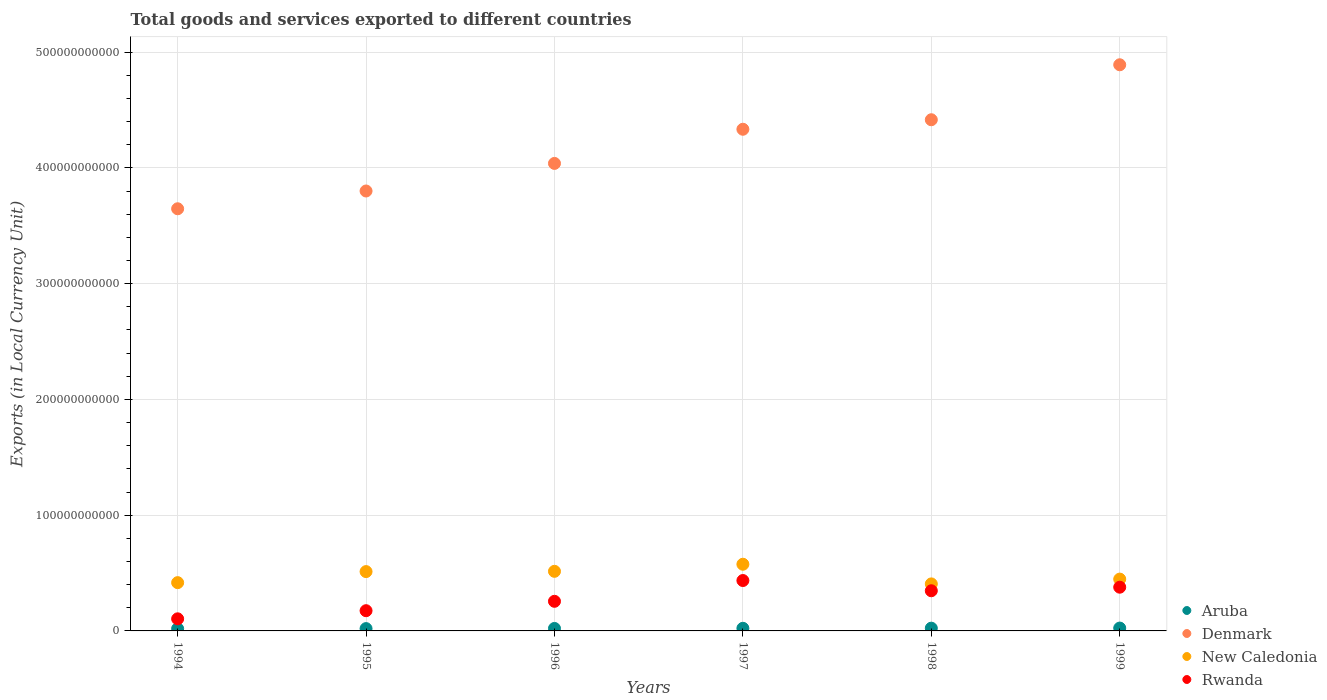What is the Amount of goods and services exports in Rwanda in 1995?
Keep it short and to the point. 1.75e+1. Across all years, what is the maximum Amount of goods and services exports in Aruba?
Ensure brevity in your answer.  2.47e+09. Across all years, what is the minimum Amount of goods and services exports in Rwanda?
Keep it short and to the point. 1.04e+1. In which year was the Amount of goods and services exports in New Caledonia maximum?
Provide a succinct answer. 1997. In which year was the Amount of goods and services exports in New Caledonia minimum?
Keep it short and to the point. 1998. What is the total Amount of goods and services exports in Aruba in the graph?
Offer a terse response. 1.32e+1. What is the difference between the Amount of goods and services exports in New Caledonia in 1994 and that in 1998?
Ensure brevity in your answer.  1.09e+09. What is the difference between the Amount of goods and services exports in Rwanda in 1998 and the Amount of goods and services exports in Aruba in 1997?
Provide a short and direct response. 3.24e+1. What is the average Amount of goods and services exports in Rwanda per year?
Ensure brevity in your answer.  2.82e+1. In the year 1997, what is the difference between the Amount of goods and services exports in Denmark and Amount of goods and services exports in New Caledonia?
Your answer should be compact. 3.76e+11. In how many years, is the Amount of goods and services exports in Rwanda greater than 480000000000 LCU?
Give a very brief answer. 0. What is the ratio of the Amount of goods and services exports in Rwanda in 1997 to that in 1998?
Keep it short and to the point. 1.25. What is the difference between the highest and the second highest Amount of goods and services exports in New Caledonia?
Ensure brevity in your answer.  6.12e+09. What is the difference between the highest and the lowest Amount of goods and services exports in Aruba?
Ensure brevity in your answer.  5.50e+08. Is the sum of the Amount of goods and services exports in Aruba in 1995 and 1997 greater than the maximum Amount of goods and services exports in Rwanda across all years?
Your answer should be very brief. No. Is it the case that in every year, the sum of the Amount of goods and services exports in Denmark and Amount of goods and services exports in Aruba  is greater than the Amount of goods and services exports in New Caledonia?
Offer a terse response. Yes. How many dotlines are there?
Your response must be concise. 4. What is the difference between two consecutive major ticks on the Y-axis?
Give a very brief answer. 1.00e+11. Are the values on the major ticks of Y-axis written in scientific E-notation?
Your answer should be very brief. No. Does the graph contain grids?
Give a very brief answer. Yes. What is the title of the graph?
Your answer should be compact. Total goods and services exported to different countries. What is the label or title of the Y-axis?
Keep it short and to the point. Exports (in Local Currency Unit). What is the Exports (in Local Currency Unit) in Aruba in 1994?
Provide a short and direct response. 1.92e+09. What is the Exports (in Local Currency Unit) in Denmark in 1994?
Your answer should be compact. 3.65e+11. What is the Exports (in Local Currency Unit) of New Caledonia in 1994?
Offer a very short reply. 4.17e+1. What is the Exports (in Local Currency Unit) in Rwanda in 1994?
Ensure brevity in your answer.  1.04e+1. What is the Exports (in Local Currency Unit) of Aruba in 1995?
Give a very brief answer. 2.01e+09. What is the Exports (in Local Currency Unit) in Denmark in 1995?
Your answer should be very brief. 3.80e+11. What is the Exports (in Local Currency Unit) in New Caledonia in 1995?
Offer a very short reply. 5.13e+1. What is the Exports (in Local Currency Unit) in Rwanda in 1995?
Provide a short and direct response. 1.75e+1. What is the Exports (in Local Currency Unit) of Aruba in 1996?
Provide a short and direct response. 2.14e+09. What is the Exports (in Local Currency Unit) of Denmark in 1996?
Provide a short and direct response. 4.04e+11. What is the Exports (in Local Currency Unit) of New Caledonia in 1996?
Make the answer very short. 5.15e+1. What is the Exports (in Local Currency Unit) in Rwanda in 1996?
Ensure brevity in your answer.  2.56e+1. What is the Exports (in Local Currency Unit) of Aruba in 1997?
Offer a terse response. 2.26e+09. What is the Exports (in Local Currency Unit) in Denmark in 1997?
Your answer should be compact. 4.33e+11. What is the Exports (in Local Currency Unit) of New Caledonia in 1997?
Your response must be concise. 5.76e+1. What is the Exports (in Local Currency Unit) in Rwanda in 1997?
Give a very brief answer. 4.35e+1. What is the Exports (in Local Currency Unit) of Aruba in 1998?
Ensure brevity in your answer.  2.37e+09. What is the Exports (in Local Currency Unit) of Denmark in 1998?
Offer a terse response. 4.42e+11. What is the Exports (in Local Currency Unit) of New Caledonia in 1998?
Provide a short and direct response. 4.06e+1. What is the Exports (in Local Currency Unit) of Rwanda in 1998?
Make the answer very short. 3.47e+1. What is the Exports (in Local Currency Unit) in Aruba in 1999?
Offer a very short reply. 2.47e+09. What is the Exports (in Local Currency Unit) in Denmark in 1999?
Keep it short and to the point. 4.89e+11. What is the Exports (in Local Currency Unit) of New Caledonia in 1999?
Offer a terse response. 4.48e+1. What is the Exports (in Local Currency Unit) of Rwanda in 1999?
Offer a very short reply. 3.78e+1. Across all years, what is the maximum Exports (in Local Currency Unit) of Aruba?
Keep it short and to the point. 2.47e+09. Across all years, what is the maximum Exports (in Local Currency Unit) in Denmark?
Give a very brief answer. 4.89e+11. Across all years, what is the maximum Exports (in Local Currency Unit) of New Caledonia?
Ensure brevity in your answer.  5.76e+1. Across all years, what is the maximum Exports (in Local Currency Unit) in Rwanda?
Your answer should be very brief. 4.35e+1. Across all years, what is the minimum Exports (in Local Currency Unit) in Aruba?
Offer a very short reply. 1.92e+09. Across all years, what is the minimum Exports (in Local Currency Unit) in Denmark?
Your answer should be compact. 3.65e+11. Across all years, what is the minimum Exports (in Local Currency Unit) of New Caledonia?
Offer a terse response. 4.06e+1. Across all years, what is the minimum Exports (in Local Currency Unit) in Rwanda?
Make the answer very short. 1.04e+1. What is the total Exports (in Local Currency Unit) of Aruba in the graph?
Your response must be concise. 1.32e+1. What is the total Exports (in Local Currency Unit) of Denmark in the graph?
Make the answer very short. 2.51e+12. What is the total Exports (in Local Currency Unit) of New Caledonia in the graph?
Give a very brief answer. 2.87e+11. What is the total Exports (in Local Currency Unit) of Rwanda in the graph?
Provide a short and direct response. 1.69e+11. What is the difference between the Exports (in Local Currency Unit) of Aruba in 1994 and that in 1995?
Make the answer very short. -9.10e+07. What is the difference between the Exports (in Local Currency Unit) of Denmark in 1994 and that in 1995?
Provide a short and direct response. -1.53e+1. What is the difference between the Exports (in Local Currency Unit) in New Caledonia in 1994 and that in 1995?
Keep it short and to the point. -9.54e+09. What is the difference between the Exports (in Local Currency Unit) in Rwanda in 1994 and that in 1995?
Your response must be concise. -7.02e+09. What is the difference between the Exports (in Local Currency Unit) in Aruba in 1994 and that in 1996?
Offer a very short reply. -2.25e+08. What is the difference between the Exports (in Local Currency Unit) in Denmark in 1994 and that in 1996?
Make the answer very short. -3.92e+1. What is the difference between the Exports (in Local Currency Unit) in New Caledonia in 1994 and that in 1996?
Your answer should be very brief. -9.78e+09. What is the difference between the Exports (in Local Currency Unit) of Rwanda in 1994 and that in 1996?
Keep it short and to the point. -1.51e+1. What is the difference between the Exports (in Local Currency Unit) of Aruba in 1994 and that in 1997?
Your response must be concise. -3.48e+08. What is the difference between the Exports (in Local Currency Unit) of Denmark in 1994 and that in 1997?
Give a very brief answer. -6.87e+1. What is the difference between the Exports (in Local Currency Unit) of New Caledonia in 1994 and that in 1997?
Provide a succinct answer. -1.59e+1. What is the difference between the Exports (in Local Currency Unit) in Rwanda in 1994 and that in 1997?
Your answer should be very brief. -3.31e+1. What is the difference between the Exports (in Local Currency Unit) in Aruba in 1994 and that in 1998?
Offer a terse response. -4.59e+08. What is the difference between the Exports (in Local Currency Unit) of Denmark in 1994 and that in 1998?
Your response must be concise. -7.69e+1. What is the difference between the Exports (in Local Currency Unit) of New Caledonia in 1994 and that in 1998?
Ensure brevity in your answer.  1.09e+09. What is the difference between the Exports (in Local Currency Unit) of Rwanda in 1994 and that in 1998?
Provide a succinct answer. -2.43e+1. What is the difference between the Exports (in Local Currency Unit) in Aruba in 1994 and that in 1999?
Offer a very short reply. -5.50e+08. What is the difference between the Exports (in Local Currency Unit) of Denmark in 1994 and that in 1999?
Offer a terse response. -1.24e+11. What is the difference between the Exports (in Local Currency Unit) of New Caledonia in 1994 and that in 1999?
Offer a very short reply. -3.06e+09. What is the difference between the Exports (in Local Currency Unit) of Rwanda in 1994 and that in 1999?
Your answer should be very brief. -2.73e+1. What is the difference between the Exports (in Local Currency Unit) of Aruba in 1995 and that in 1996?
Your answer should be compact. -1.34e+08. What is the difference between the Exports (in Local Currency Unit) in Denmark in 1995 and that in 1996?
Your answer should be very brief. -2.38e+1. What is the difference between the Exports (in Local Currency Unit) of New Caledonia in 1995 and that in 1996?
Provide a succinct answer. -2.33e+08. What is the difference between the Exports (in Local Currency Unit) of Rwanda in 1995 and that in 1996?
Give a very brief answer. -8.11e+09. What is the difference between the Exports (in Local Currency Unit) of Aruba in 1995 and that in 1997?
Offer a terse response. -2.57e+08. What is the difference between the Exports (in Local Currency Unit) of Denmark in 1995 and that in 1997?
Provide a short and direct response. -5.33e+1. What is the difference between the Exports (in Local Currency Unit) in New Caledonia in 1995 and that in 1997?
Give a very brief answer. -6.35e+09. What is the difference between the Exports (in Local Currency Unit) of Rwanda in 1995 and that in 1997?
Your answer should be very brief. -2.61e+1. What is the difference between the Exports (in Local Currency Unit) of Aruba in 1995 and that in 1998?
Make the answer very short. -3.68e+08. What is the difference between the Exports (in Local Currency Unit) in Denmark in 1995 and that in 1998?
Ensure brevity in your answer.  -6.16e+1. What is the difference between the Exports (in Local Currency Unit) of New Caledonia in 1995 and that in 1998?
Ensure brevity in your answer.  1.06e+1. What is the difference between the Exports (in Local Currency Unit) of Rwanda in 1995 and that in 1998?
Make the answer very short. -1.72e+1. What is the difference between the Exports (in Local Currency Unit) in Aruba in 1995 and that in 1999?
Provide a short and direct response. -4.59e+08. What is the difference between the Exports (in Local Currency Unit) in Denmark in 1995 and that in 1999?
Keep it short and to the point. -1.09e+11. What is the difference between the Exports (in Local Currency Unit) of New Caledonia in 1995 and that in 1999?
Your response must be concise. 6.49e+09. What is the difference between the Exports (in Local Currency Unit) in Rwanda in 1995 and that in 1999?
Make the answer very short. -2.03e+1. What is the difference between the Exports (in Local Currency Unit) of Aruba in 1996 and that in 1997?
Make the answer very short. -1.23e+08. What is the difference between the Exports (in Local Currency Unit) of Denmark in 1996 and that in 1997?
Your answer should be compact. -2.95e+1. What is the difference between the Exports (in Local Currency Unit) of New Caledonia in 1996 and that in 1997?
Your answer should be compact. -6.12e+09. What is the difference between the Exports (in Local Currency Unit) in Rwanda in 1996 and that in 1997?
Ensure brevity in your answer.  -1.80e+1. What is the difference between the Exports (in Local Currency Unit) in Aruba in 1996 and that in 1998?
Give a very brief answer. -2.34e+08. What is the difference between the Exports (in Local Currency Unit) of Denmark in 1996 and that in 1998?
Ensure brevity in your answer.  -3.77e+1. What is the difference between the Exports (in Local Currency Unit) of New Caledonia in 1996 and that in 1998?
Your answer should be very brief. 1.09e+1. What is the difference between the Exports (in Local Currency Unit) of Rwanda in 1996 and that in 1998?
Ensure brevity in your answer.  -9.12e+09. What is the difference between the Exports (in Local Currency Unit) in Aruba in 1996 and that in 1999?
Your response must be concise. -3.25e+08. What is the difference between the Exports (in Local Currency Unit) in Denmark in 1996 and that in 1999?
Keep it short and to the point. -8.52e+1. What is the difference between the Exports (in Local Currency Unit) of New Caledonia in 1996 and that in 1999?
Provide a short and direct response. 6.72e+09. What is the difference between the Exports (in Local Currency Unit) in Rwanda in 1996 and that in 1999?
Provide a succinct answer. -1.22e+1. What is the difference between the Exports (in Local Currency Unit) of Aruba in 1997 and that in 1998?
Offer a very short reply. -1.11e+08. What is the difference between the Exports (in Local Currency Unit) in Denmark in 1997 and that in 1998?
Give a very brief answer. -8.22e+09. What is the difference between the Exports (in Local Currency Unit) of New Caledonia in 1997 and that in 1998?
Keep it short and to the point. 1.70e+1. What is the difference between the Exports (in Local Currency Unit) in Rwanda in 1997 and that in 1998?
Ensure brevity in your answer.  8.83e+09. What is the difference between the Exports (in Local Currency Unit) of Aruba in 1997 and that in 1999?
Your response must be concise. -2.02e+08. What is the difference between the Exports (in Local Currency Unit) in Denmark in 1997 and that in 1999?
Provide a succinct answer. -5.57e+1. What is the difference between the Exports (in Local Currency Unit) of New Caledonia in 1997 and that in 1999?
Offer a very short reply. 1.28e+1. What is the difference between the Exports (in Local Currency Unit) in Rwanda in 1997 and that in 1999?
Give a very brief answer. 5.77e+09. What is the difference between the Exports (in Local Currency Unit) of Aruba in 1998 and that in 1999?
Offer a very short reply. -9.15e+07. What is the difference between the Exports (in Local Currency Unit) in Denmark in 1998 and that in 1999?
Ensure brevity in your answer.  -4.75e+1. What is the difference between the Exports (in Local Currency Unit) of New Caledonia in 1998 and that in 1999?
Your response must be concise. -4.14e+09. What is the difference between the Exports (in Local Currency Unit) in Rwanda in 1998 and that in 1999?
Your response must be concise. -3.07e+09. What is the difference between the Exports (in Local Currency Unit) in Aruba in 1994 and the Exports (in Local Currency Unit) in Denmark in 1995?
Make the answer very short. -3.78e+11. What is the difference between the Exports (in Local Currency Unit) in Aruba in 1994 and the Exports (in Local Currency Unit) in New Caledonia in 1995?
Keep it short and to the point. -4.93e+1. What is the difference between the Exports (in Local Currency Unit) in Aruba in 1994 and the Exports (in Local Currency Unit) in Rwanda in 1995?
Your answer should be very brief. -1.56e+1. What is the difference between the Exports (in Local Currency Unit) in Denmark in 1994 and the Exports (in Local Currency Unit) in New Caledonia in 1995?
Provide a short and direct response. 3.13e+11. What is the difference between the Exports (in Local Currency Unit) in Denmark in 1994 and the Exports (in Local Currency Unit) in Rwanda in 1995?
Your answer should be compact. 3.47e+11. What is the difference between the Exports (in Local Currency Unit) in New Caledonia in 1994 and the Exports (in Local Currency Unit) in Rwanda in 1995?
Provide a succinct answer. 2.42e+1. What is the difference between the Exports (in Local Currency Unit) of Aruba in 1994 and the Exports (in Local Currency Unit) of Denmark in 1996?
Give a very brief answer. -4.02e+11. What is the difference between the Exports (in Local Currency Unit) of Aruba in 1994 and the Exports (in Local Currency Unit) of New Caledonia in 1996?
Make the answer very short. -4.96e+1. What is the difference between the Exports (in Local Currency Unit) of Aruba in 1994 and the Exports (in Local Currency Unit) of Rwanda in 1996?
Keep it short and to the point. -2.37e+1. What is the difference between the Exports (in Local Currency Unit) in Denmark in 1994 and the Exports (in Local Currency Unit) in New Caledonia in 1996?
Offer a terse response. 3.13e+11. What is the difference between the Exports (in Local Currency Unit) of Denmark in 1994 and the Exports (in Local Currency Unit) of Rwanda in 1996?
Ensure brevity in your answer.  3.39e+11. What is the difference between the Exports (in Local Currency Unit) of New Caledonia in 1994 and the Exports (in Local Currency Unit) of Rwanda in 1996?
Give a very brief answer. 1.61e+1. What is the difference between the Exports (in Local Currency Unit) of Aruba in 1994 and the Exports (in Local Currency Unit) of Denmark in 1997?
Ensure brevity in your answer.  -4.31e+11. What is the difference between the Exports (in Local Currency Unit) in Aruba in 1994 and the Exports (in Local Currency Unit) in New Caledonia in 1997?
Your answer should be very brief. -5.57e+1. What is the difference between the Exports (in Local Currency Unit) in Aruba in 1994 and the Exports (in Local Currency Unit) in Rwanda in 1997?
Your answer should be very brief. -4.16e+1. What is the difference between the Exports (in Local Currency Unit) of Denmark in 1994 and the Exports (in Local Currency Unit) of New Caledonia in 1997?
Ensure brevity in your answer.  3.07e+11. What is the difference between the Exports (in Local Currency Unit) of Denmark in 1994 and the Exports (in Local Currency Unit) of Rwanda in 1997?
Make the answer very short. 3.21e+11. What is the difference between the Exports (in Local Currency Unit) in New Caledonia in 1994 and the Exports (in Local Currency Unit) in Rwanda in 1997?
Your response must be concise. -1.83e+09. What is the difference between the Exports (in Local Currency Unit) in Aruba in 1994 and the Exports (in Local Currency Unit) in Denmark in 1998?
Keep it short and to the point. -4.40e+11. What is the difference between the Exports (in Local Currency Unit) of Aruba in 1994 and the Exports (in Local Currency Unit) of New Caledonia in 1998?
Make the answer very short. -3.87e+1. What is the difference between the Exports (in Local Currency Unit) of Aruba in 1994 and the Exports (in Local Currency Unit) of Rwanda in 1998?
Your response must be concise. -3.28e+1. What is the difference between the Exports (in Local Currency Unit) of Denmark in 1994 and the Exports (in Local Currency Unit) of New Caledonia in 1998?
Provide a succinct answer. 3.24e+11. What is the difference between the Exports (in Local Currency Unit) in Denmark in 1994 and the Exports (in Local Currency Unit) in Rwanda in 1998?
Provide a short and direct response. 3.30e+11. What is the difference between the Exports (in Local Currency Unit) of New Caledonia in 1994 and the Exports (in Local Currency Unit) of Rwanda in 1998?
Ensure brevity in your answer.  7.01e+09. What is the difference between the Exports (in Local Currency Unit) in Aruba in 1994 and the Exports (in Local Currency Unit) in Denmark in 1999?
Keep it short and to the point. -4.87e+11. What is the difference between the Exports (in Local Currency Unit) of Aruba in 1994 and the Exports (in Local Currency Unit) of New Caledonia in 1999?
Your response must be concise. -4.28e+1. What is the difference between the Exports (in Local Currency Unit) of Aruba in 1994 and the Exports (in Local Currency Unit) of Rwanda in 1999?
Make the answer very short. -3.59e+1. What is the difference between the Exports (in Local Currency Unit) in Denmark in 1994 and the Exports (in Local Currency Unit) in New Caledonia in 1999?
Offer a terse response. 3.20e+11. What is the difference between the Exports (in Local Currency Unit) of Denmark in 1994 and the Exports (in Local Currency Unit) of Rwanda in 1999?
Your answer should be compact. 3.27e+11. What is the difference between the Exports (in Local Currency Unit) in New Caledonia in 1994 and the Exports (in Local Currency Unit) in Rwanda in 1999?
Offer a terse response. 3.94e+09. What is the difference between the Exports (in Local Currency Unit) in Aruba in 1995 and the Exports (in Local Currency Unit) in Denmark in 1996?
Your answer should be compact. -4.02e+11. What is the difference between the Exports (in Local Currency Unit) of Aruba in 1995 and the Exports (in Local Currency Unit) of New Caledonia in 1996?
Give a very brief answer. -4.95e+1. What is the difference between the Exports (in Local Currency Unit) of Aruba in 1995 and the Exports (in Local Currency Unit) of Rwanda in 1996?
Your answer should be very brief. -2.36e+1. What is the difference between the Exports (in Local Currency Unit) in Denmark in 1995 and the Exports (in Local Currency Unit) in New Caledonia in 1996?
Give a very brief answer. 3.29e+11. What is the difference between the Exports (in Local Currency Unit) of Denmark in 1995 and the Exports (in Local Currency Unit) of Rwanda in 1996?
Offer a very short reply. 3.54e+11. What is the difference between the Exports (in Local Currency Unit) of New Caledonia in 1995 and the Exports (in Local Currency Unit) of Rwanda in 1996?
Ensure brevity in your answer.  2.57e+1. What is the difference between the Exports (in Local Currency Unit) of Aruba in 1995 and the Exports (in Local Currency Unit) of Denmark in 1997?
Provide a succinct answer. -4.31e+11. What is the difference between the Exports (in Local Currency Unit) of Aruba in 1995 and the Exports (in Local Currency Unit) of New Caledonia in 1997?
Your answer should be very brief. -5.56e+1. What is the difference between the Exports (in Local Currency Unit) in Aruba in 1995 and the Exports (in Local Currency Unit) in Rwanda in 1997?
Provide a short and direct response. -4.15e+1. What is the difference between the Exports (in Local Currency Unit) in Denmark in 1995 and the Exports (in Local Currency Unit) in New Caledonia in 1997?
Provide a succinct answer. 3.22e+11. What is the difference between the Exports (in Local Currency Unit) in Denmark in 1995 and the Exports (in Local Currency Unit) in Rwanda in 1997?
Offer a very short reply. 3.37e+11. What is the difference between the Exports (in Local Currency Unit) of New Caledonia in 1995 and the Exports (in Local Currency Unit) of Rwanda in 1997?
Your response must be concise. 7.72e+09. What is the difference between the Exports (in Local Currency Unit) of Aruba in 1995 and the Exports (in Local Currency Unit) of Denmark in 1998?
Provide a short and direct response. -4.40e+11. What is the difference between the Exports (in Local Currency Unit) of Aruba in 1995 and the Exports (in Local Currency Unit) of New Caledonia in 1998?
Keep it short and to the point. -3.86e+1. What is the difference between the Exports (in Local Currency Unit) in Aruba in 1995 and the Exports (in Local Currency Unit) in Rwanda in 1998?
Make the answer very short. -3.27e+1. What is the difference between the Exports (in Local Currency Unit) in Denmark in 1995 and the Exports (in Local Currency Unit) in New Caledonia in 1998?
Your answer should be very brief. 3.39e+11. What is the difference between the Exports (in Local Currency Unit) in Denmark in 1995 and the Exports (in Local Currency Unit) in Rwanda in 1998?
Your response must be concise. 3.45e+11. What is the difference between the Exports (in Local Currency Unit) of New Caledonia in 1995 and the Exports (in Local Currency Unit) of Rwanda in 1998?
Provide a short and direct response. 1.66e+1. What is the difference between the Exports (in Local Currency Unit) in Aruba in 1995 and the Exports (in Local Currency Unit) in Denmark in 1999?
Provide a short and direct response. -4.87e+11. What is the difference between the Exports (in Local Currency Unit) of Aruba in 1995 and the Exports (in Local Currency Unit) of New Caledonia in 1999?
Your answer should be compact. -4.28e+1. What is the difference between the Exports (in Local Currency Unit) in Aruba in 1995 and the Exports (in Local Currency Unit) in Rwanda in 1999?
Keep it short and to the point. -3.58e+1. What is the difference between the Exports (in Local Currency Unit) of Denmark in 1995 and the Exports (in Local Currency Unit) of New Caledonia in 1999?
Your answer should be very brief. 3.35e+11. What is the difference between the Exports (in Local Currency Unit) of Denmark in 1995 and the Exports (in Local Currency Unit) of Rwanda in 1999?
Provide a short and direct response. 3.42e+11. What is the difference between the Exports (in Local Currency Unit) in New Caledonia in 1995 and the Exports (in Local Currency Unit) in Rwanda in 1999?
Your answer should be compact. 1.35e+1. What is the difference between the Exports (in Local Currency Unit) in Aruba in 1996 and the Exports (in Local Currency Unit) in Denmark in 1997?
Ensure brevity in your answer.  -4.31e+11. What is the difference between the Exports (in Local Currency Unit) of Aruba in 1996 and the Exports (in Local Currency Unit) of New Caledonia in 1997?
Give a very brief answer. -5.55e+1. What is the difference between the Exports (in Local Currency Unit) of Aruba in 1996 and the Exports (in Local Currency Unit) of Rwanda in 1997?
Provide a succinct answer. -4.14e+1. What is the difference between the Exports (in Local Currency Unit) of Denmark in 1996 and the Exports (in Local Currency Unit) of New Caledonia in 1997?
Provide a short and direct response. 3.46e+11. What is the difference between the Exports (in Local Currency Unit) in Denmark in 1996 and the Exports (in Local Currency Unit) in Rwanda in 1997?
Offer a very short reply. 3.60e+11. What is the difference between the Exports (in Local Currency Unit) in New Caledonia in 1996 and the Exports (in Local Currency Unit) in Rwanda in 1997?
Make the answer very short. 7.95e+09. What is the difference between the Exports (in Local Currency Unit) in Aruba in 1996 and the Exports (in Local Currency Unit) in Denmark in 1998?
Keep it short and to the point. -4.39e+11. What is the difference between the Exports (in Local Currency Unit) of Aruba in 1996 and the Exports (in Local Currency Unit) of New Caledonia in 1998?
Give a very brief answer. -3.85e+1. What is the difference between the Exports (in Local Currency Unit) of Aruba in 1996 and the Exports (in Local Currency Unit) of Rwanda in 1998?
Provide a succinct answer. -3.26e+1. What is the difference between the Exports (in Local Currency Unit) of Denmark in 1996 and the Exports (in Local Currency Unit) of New Caledonia in 1998?
Keep it short and to the point. 3.63e+11. What is the difference between the Exports (in Local Currency Unit) in Denmark in 1996 and the Exports (in Local Currency Unit) in Rwanda in 1998?
Your response must be concise. 3.69e+11. What is the difference between the Exports (in Local Currency Unit) in New Caledonia in 1996 and the Exports (in Local Currency Unit) in Rwanda in 1998?
Offer a very short reply. 1.68e+1. What is the difference between the Exports (in Local Currency Unit) of Aruba in 1996 and the Exports (in Local Currency Unit) of Denmark in 1999?
Offer a very short reply. -4.87e+11. What is the difference between the Exports (in Local Currency Unit) in Aruba in 1996 and the Exports (in Local Currency Unit) in New Caledonia in 1999?
Your response must be concise. -4.26e+1. What is the difference between the Exports (in Local Currency Unit) in Aruba in 1996 and the Exports (in Local Currency Unit) in Rwanda in 1999?
Provide a short and direct response. -3.56e+1. What is the difference between the Exports (in Local Currency Unit) of Denmark in 1996 and the Exports (in Local Currency Unit) of New Caledonia in 1999?
Ensure brevity in your answer.  3.59e+11. What is the difference between the Exports (in Local Currency Unit) of Denmark in 1996 and the Exports (in Local Currency Unit) of Rwanda in 1999?
Your answer should be compact. 3.66e+11. What is the difference between the Exports (in Local Currency Unit) of New Caledonia in 1996 and the Exports (in Local Currency Unit) of Rwanda in 1999?
Keep it short and to the point. 1.37e+1. What is the difference between the Exports (in Local Currency Unit) of Aruba in 1997 and the Exports (in Local Currency Unit) of Denmark in 1998?
Provide a succinct answer. -4.39e+11. What is the difference between the Exports (in Local Currency Unit) of Aruba in 1997 and the Exports (in Local Currency Unit) of New Caledonia in 1998?
Give a very brief answer. -3.84e+1. What is the difference between the Exports (in Local Currency Unit) in Aruba in 1997 and the Exports (in Local Currency Unit) in Rwanda in 1998?
Your answer should be very brief. -3.24e+1. What is the difference between the Exports (in Local Currency Unit) of Denmark in 1997 and the Exports (in Local Currency Unit) of New Caledonia in 1998?
Offer a very short reply. 3.93e+11. What is the difference between the Exports (in Local Currency Unit) in Denmark in 1997 and the Exports (in Local Currency Unit) in Rwanda in 1998?
Offer a very short reply. 3.99e+11. What is the difference between the Exports (in Local Currency Unit) of New Caledonia in 1997 and the Exports (in Local Currency Unit) of Rwanda in 1998?
Offer a very short reply. 2.29e+1. What is the difference between the Exports (in Local Currency Unit) of Aruba in 1997 and the Exports (in Local Currency Unit) of Denmark in 1999?
Offer a very short reply. -4.87e+11. What is the difference between the Exports (in Local Currency Unit) in Aruba in 1997 and the Exports (in Local Currency Unit) in New Caledonia in 1999?
Provide a short and direct response. -4.25e+1. What is the difference between the Exports (in Local Currency Unit) of Aruba in 1997 and the Exports (in Local Currency Unit) of Rwanda in 1999?
Give a very brief answer. -3.55e+1. What is the difference between the Exports (in Local Currency Unit) in Denmark in 1997 and the Exports (in Local Currency Unit) in New Caledonia in 1999?
Offer a very short reply. 3.89e+11. What is the difference between the Exports (in Local Currency Unit) of Denmark in 1997 and the Exports (in Local Currency Unit) of Rwanda in 1999?
Provide a succinct answer. 3.96e+11. What is the difference between the Exports (in Local Currency Unit) of New Caledonia in 1997 and the Exports (in Local Currency Unit) of Rwanda in 1999?
Keep it short and to the point. 1.98e+1. What is the difference between the Exports (in Local Currency Unit) in Aruba in 1998 and the Exports (in Local Currency Unit) in Denmark in 1999?
Your answer should be compact. -4.87e+11. What is the difference between the Exports (in Local Currency Unit) of Aruba in 1998 and the Exports (in Local Currency Unit) of New Caledonia in 1999?
Ensure brevity in your answer.  -4.24e+1. What is the difference between the Exports (in Local Currency Unit) of Aruba in 1998 and the Exports (in Local Currency Unit) of Rwanda in 1999?
Make the answer very short. -3.54e+1. What is the difference between the Exports (in Local Currency Unit) of Denmark in 1998 and the Exports (in Local Currency Unit) of New Caledonia in 1999?
Ensure brevity in your answer.  3.97e+11. What is the difference between the Exports (in Local Currency Unit) in Denmark in 1998 and the Exports (in Local Currency Unit) in Rwanda in 1999?
Give a very brief answer. 4.04e+11. What is the difference between the Exports (in Local Currency Unit) of New Caledonia in 1998 and the Exports (in Local Currency Unit) of Rwanda in 1999?
Your answer should be compact. 2.85e+09. What is the average Exports (in Local Currency Unit) in Aruba per year?
Offer a very short reply. 2.19e+09. What is the average Exports (in Local Currency Unit) in Denmark per year?
Your response must be concise. 4.19e+11. What is the average Exports (in Local Currency Unit) in New Caledonia per year?
Provide a succinct answer. 4.79e+1. What is the average Exports (in Local Currency Unit) of Rwanda per year?
Provide a short and direct response. 2.82e+1. In the year 1994, what is the difference between the Exports (in Local Currency Unit) in Aruba and Exports (in Local Currency Unit) in Denmark?
Your response must be concise. -3.63e+11. In the year 1994, what is the difference between the Exports (in Local Currency Unit) of Aruba and Exports (in Local Currency Unit) of New Caledonia?
Your response must be concise. -3.98e+1. In the year 1994, what is the difference between the Exports (in Local Currency Unit) of Aruba and Exports (in Local Currency Unit) of Rwanda?
Your response must be concise. -8.53e+09. In the year 1994, what is the difference between the Exports (in Local Currency Unit) in Denmark and Exports (in Local Currency Unit) in New Caledonia?
Your answer should be compact. 3.23e+11. In the year 1994, what is the difference between the Exports (in Local Currency Unit) of Denmark and Exports (in Local Currency Unit) of Rwanda?
Give a very brief answer. 3.54e+11. In the year 1994, what is the difference between the Exports (in Local Currency Unit) in New Caledonia and Exports (in Local Currency Unit) in Rwanda?
Your answer should be very brief. 3.13e+1. In the year 1995, what is the difference between the Exports (in Local Currency Unit) of Aruba and Exports (in Local Currency Unit) of Denmark?
Your answer should be very brief. -3.78e+11. In the year 1995, what is the difference between the Exports (in Local Currency Unit) in Aruba and Exports (in Local Currency Unit) in New Caledonia?
Give a very brief answer. -4.92e+1. In the year 1995, what is the difference between the Exports (in Local Currency Unit) in Aruba and Exports (in Local Currency Unit) in Rwanda?
Provide a succinct answer. -1.55e+1. In the year 1995, what is the difference between the Exports (in Local Currency Unit) in Denmark and Exports (in Local Currency Unit) in New Caledonia?
Make the answer very short. 3.29e+11. In the year 1995, what is the difference between the Exports (in Local Currency Unit) of Denmark and Exports (in Local Currency Unit) of Rwanda?
Make the answer very short. 3.63e+11. In the year 1995, what is the difference between the Exports (in Local Currency Unit) of New Caledonia and Exports (in Local Currency Unit) of Rwanda?
Your answer should be compact. 3.38e+1. In the year 1996, what is the difference between the Exports (in Local Currency Unit) in Aruba and Exports (in Local Currency Unit) in Denmark?
Keep it short and to the point. -4.02e+11. In the year 1996, what is the difference between the Exports (in Local Currency Unit) of Aruba and Exports (in Local Currency Unit) of New Caledonia?
Ensure brevity in your answer.  -4.93e+1. In the year 1996, what is the difference between the Exports (in Local Currency Unit) of Aruba and Exports (in Local Currency Unit) of Rwanda?
Provide a succinct answer. -2.34e+1. In the year 1996, what is the difference between the Exports (in Local Currency Unit) of Denmark and Exports (in Local Currency Unit) of New Caledonia?
Provide a succinct answer. 3.52e+11. In the year 1996, what is the difference between the Exports (in Local Currency Unit) of Denmark and Exports (in Local Currency Unit) of Rwanda?
Provide a short and direct response. 3.78e+11. In the year 1996, what is the difference between the Exports (in Local Currency Unit) in New Caledonia and Exports (in Local Currency Unit) in Rwanda?
Give a very brief answer. 2.59e+1. In the year 1997, what is the difference between the Exports (in Local Currency Unit) in Aruba and Exports (in Local Currency Unit) in Denmark?
Make the answer very short. -4.31e+11. In the year 1997, what is the difference between the Exports (in Local Currency Unit) of Aruba and Exports (in Local Currency Unit) of New Caledonia?
Give a very brief answer. -5.53e+1. In the year 1997, what is the difference between the Exports (in Local Currency Unit) in Aruba and Exports (in Local Currency Unit) in Rwanda?
Make the answer very short. -4.13e+1. In the year 1997, what is the difference between the Exports (in Local Currency Unit) of Denmark and Exports (in Local Currency Unit) of New Caledonia?
Ensure brevity in your answer.  3.76e+11. In the year 1997, what is the difference between the Exports (in Local Currency Unit) in Denmark and Exports (in Local Currency Unit) in Rwanda?
Ensure brevity in your answer.  3.90e+11. In the year 1997, what is the difference between the Exports (in Local Currency Unit) of New Caledonia and Exports (in Local Currency Unit) of Rwanda?
Your response must be concise. 1.41e+1. In the year 1998, what is the difference between the Exports (in Local Currency Unit) of Aruba and Exports (in Local Currency Unit) of Denmark?
Your answer should be very brief. -4.39e+11. In the year 1998, what is the difference between the Exports (in Local Currency Unit) in Aruba and Exports (in Local Currency Unit) in New Caledonia?
Ensure brevity in your answer.  -3.82e+1. In the year 1998, what is the difference between the Exports (in Local Currency Unit) of Aruba and Exports (in Local Currency Unit) of Rwanda?
Your answer should be compact. -3.23e+1. In the year 1998, what is the difference between the Exports (in Local Currency Unit) in Denmark and Exports (in Local Currency Unit) in New Caledonia?
Provide a short and direct response. 4.01e+11. In the year 1998, what is the difference between the Exports (in Local Currency Unit) in Denmark and Exports (in Local Currency Unit) in Rwanda?
Give a very brief answer. 4.07e+11. In the year 1998, what is the difference between the Exports (in Local Currency Unit) in New Caledonia and Exports (in Local Currency Unit) in Rwanda?
Your response must be concise. 5.92e+09. In the year 1999, what is the difference between the Exports (in Local Currency Unit) in Aruba and Exports (in Local Currency Unit) in Denmark?
Give a very brief answer. -4.87e+11. In the year 1999, what is the difference between the Exports (in Local Currency Unit) in Aruba and Exports (in Local Currency Unit) in New Caledonia?
Your answer should be compact. -4.23e+1. In the year 1999, what is the difference between the Exports (in Local Currency Unit) of Aruba and Exports (in Local Currency Unit) of Rwanda?
Provide a succinct answer. -3.53e+1. In the year 1999, what is the difference between the Exports (in Local Currency Unit) in Denmark and Exports (in Local Currency Unit) in New Caledonia?
Keep it short and to the point. 4.44e+11. In the year 1999, what is the difference between the Exports (in Local Currency Unit) in Denmark and Exports (in Local Currency Unit) in Rwanda?
Provide a succinct answer. 4.51e+11. In the year 1999, what is the difference between the Exports (in Local Currency Unit) of New Caledonia and Exports (in Local Currency Unit) of Rwanda?
Make the answer very short. 7.00e+09. What is the ratio of the Exports (in Local Currency Unit) in Aruba in 1994 to that in 1995?
Offer a very short reply. 0.95. What is the ratio of the Exports (in Local Currency Unit) in Denmark in 1994 to that in 1995?
Your answer should be very brief. 0.96. What is the ratio of the Exports (in Local Currency Unit) in New Caledonia in 1994 to that in 1995?
Offer a terse response. 0.81. What is the ratio of the Exports (in Local Currency Unit) of Rwanda in 1994 to that in 1995?
Your response must be concise. 0.6. What is the ratio of the Exports (in Local Currency Unit) of Aruba in 1994 to that in 1996?
Make the answer very short. 0.89. What is the ratio of the Exports (in Local Currency Unit) of Denmark in 1994 to that in 1996?
Your answer should be compact. 0.9. What is the ratio of the Exports (in Local Currency Unit) of New Caledonia in 1994 to that in 1996?
Keep it short and to the point. 0.81. What is the ratio of the Exports (in Local Currency Unit) of Rwanda in 1994 to that in 1996?
Ensure brevity in your answer.  0.41. What is the ratio of the Exports (in Local Currency Unit) in Aruba in 1994 to that in 1997?
Your answer should be very brief. 0.85. What is the ratio of the Exports (in Local Currency Unit) of Denmark in 1994 to that in 1997?
Offer a terse response. 0.84. What is the ratio of the Exports (in Local Currency Unit) of New Caledonia in 1994 to that in 1997?
Provide a short and direct response. 0.72. What is the ratio of the Exports (in Local Currency Unit) in Rwanda in 1994 to that in 1997?
Offer a terse response. 0.24. What is the ratio of the Exports (in Local Currency Unit) of Aruba in 1994 to that in 1998?
Give a very brief answer. 0.81. What is the ratio of the Exports (in Local Currency Unit) of Denmark in 1994 to that in 1998?
Provide a succinct answer. 0.83. What is the ratio of the Exports (in Local Currency Unit) in New Caledonia in 1994 to that in 1998?
Your answer should be very brief. 1.03. What is the ratio of the Exports (in Local Currency Unit) in Rwanda in 1994 to that in 1998?
Ensure brevity in your answer.  0.3. What is the ratio of the Exports (in Local Currency Unit) in Aruba in 1994 to that in 1999?
Offer a terse response. 0.78. What is the ratio of the Exports (in Local Currency Unit) in Denmark in 1994 to that in 1999?
Provide a succinct answer. 0.75. What is the ratio of the Exports (in Local Currency Unit) of New Caledonia in 1994 to that in 1999?
Offer a very short reply. 0.93. What is the ratio of the Exports (in Local Currency Unit) of Rwanda in 1994 to that in 1999?
Offer a terse response. 0.28. What is the ratio of the Exports (in Local Currency Unit) of Aruba in 1995 to that in 1996?
Make the answer very short. 0.94. What is the ratio of the Exports (in Local Currency Unit) in Denmark in 1995 to that in 1996?
Ensure brevity in your answer.  0.94. What is the ratio of the Exports (in Local Currency Unit) of New Caledonia in 1995 to that in 1996?
Keep it short and to the point. 1. What is the ratio of the Exports (in Local Currency Unit) of Rwanda in 1995 to that in 1996?
Offer a terse response. 0.68. What is the ratio of the Exports (in Local Currency Unit) in Aruba in 1995 to that in 1997?
Give a very brief answer. 0.89. What is the ratio of the Exports (in Local Currency Unit) in Denmark in 1995 to that in 1997?
Make the answer very short. 0.88. What is the ratio of the Exports (in Local Currency Unit) in New Caledonia in 1995 to that in 1997?
Your response must be concise. 0.89. What is the ratio of the Exports (in Local Currency Unit) of Rwanda in 1995 to that in 1997?
Offer a very short reply. 0.4. What is the ratio of the Exports (in Local Currency Unit) in Aruba in 1995 to that in 1998?
Ensure brevity in your answer.  0.84. What is the ratio of the Exports (in Local Currency Unit) of Denmark in 1995 to that in 1998?
Make the answer very short. 0.86. What is the ratio of the Exports (in Local Currency Unit) in New Caledonia in 1995 to that in 1998?
Provide a short and direct response. 1.26. What is the ratio of the Exports (in Local Currency Unit) in Rwanda in 1995 to that in 1998?
Ensure brevity in your answer.  0.5. What is the ratio of the Exports (in Local Currency Unit) of Aruba in 1995 to that in 1999?
Provide a succinct answer. 0.81. What is the ratio of the Exports (in Local Currency Unit) in Denmark in 1995 to that in 1999?
Offer a terse response. 0.78. What is the ratio of the Exports (in Local Currency Unit) in New Caledonia in 1995 to that in 1999?
Ensure brevity in your answer.  1.14. What is the ratio of the Exports (in Local Currency Unit) in Rwanda in 1995 to that in 1999?
Keep it short and to the point. 0.46. What is the ratio of the Exports (in Local Currency Unit) in Aruba in 1996 to that in 1997?
Offer a terse response. 0.95. What is the ratio of the Exports (in Local Currency Unit) in Denmark in 1996 to that in 1997?
Offer a very short reply. 0.93. What is the ratio of the Exports (in Local Currency Unit) of New Caledonia in 1996 to that in 1997?
Keep it short and to the point. 0.89. What is the ratio of the Exports (in Local Currency Unit) in Rwanda in 1996 to that in 1997?
Offer a very short reply. 0.59. What is the ratio of the Exports (in Local Currency Unit) in Aruba in 1996 to that in 1998?
Your answer should be very brief. 0.9. What is the ratio of the Exports (in Local Currency Unit) in Denmark in 1996 to that in 1998?
Make the answer very short. 0.91. What is the ratio of the Exports (in Local Currency Unit) of New Caledonia in 1996 to that in 1998?
Make the answer very short. 1.27. What is the ratio of the Exports (in Local Currency Unit) in Rwanda in 1996 to that in 1998?
Provide a succinct answer. 0.74. What is the ratio of the Exports (in Local Currency Unit) of Aruba in 1996 to that in 1999?
Ensure brevity in your answer.  0.87. What is the ratio of the Exports (in Local Currency Unit) in Denmark in 1996 to that in 1999?
Offer a terse response. 0.83. What is the ratio of the Exports (in Local Currency Unit) in New Caledonia in 1996 to that in 1999?
Your answer should be compact. 1.15. What is the ratio of the Exports (in Local Currency Unit) of Rwanda in 1996 to that in 1999?
Keep it short and to the point. 0.68. What is the ratio of the Exports (in Local Currency Unit) in Aruba in 1997 to that in 1998?
Make the answer very short. 0.95. What is the ratio of the Exports (in Local Currency Unit) of Denmark in 1997 to that in 1998?
Ensure brevity in your answer.  0.98. What is the ratio of the Exports (in Local Currency Unit) in New Caledonia in 1997 to that in 1998?
Offer a very short reply. 1.42. What is the ratio of the Exports (in Local Currency Unit) of Rwanda in 1997 to that in 1998?
Ensure brevity in your answer.  1.25. What is the ratio of the Exports (in Local Currency Unit) in Aruba in 1997 to that in 1999?
Ensure brevity in your answer.  0.92. What is the ratio of the Exports (in Local Currency Unit) of Denmark in 1997 to that in 1999?
Provide a succinct answer. 0.89. What is the ratio of the Exports (in Local Currency Unit) in New Caledonia in 1997 to that in 1999?
Your answer should be very brief. 1.29. What is the ratio of the Exports (in Local Currency Unit) in Rwanda in 1997 to that in 1999?
Give a very brief answer. 1.15. What is the ratio of the Exports (in Local Currency Unit) of Aruba in 1998 to that in 1999?
Offer a very short reply. 0.96. What is the ratio of the Exports (in Local Currency Unit) of Denmark in 1998 to that in 1999?
Ensure brevity in your answer.  0.9. What is the ratio of the Exports (in Local Currency Unit) in New Caledonia in 1998 to that in 1999?
Your answer should be compact. 0.91. What is the ratio of the Exports (in Local Currency Unit) in Rwanda in 1998 to that in 1999?
Your answer should be very brief. 0.92. What is the difference between the highest and the second highest Exports (in Local Currency Unit) in Aruba?
Give a very brief answer. 9.15e+07. What is the difference between the highest and the second highest Exports (in Local Currency Unit) in Denmark?
Your answer should be very brief. 4.75e+1. What is the difference between the highest and the second highest Exports (in Local Currency Unit) in New Caledonia?
Your answer should be compact. 6.12e+09. What is the difference between the highest and the second highest Exports (in Local Currency Unit) of Rwanda?
Offer a very short reply. 5.77e+09. What is the difference between the highest and the lowest Exports (in Local Currency Unit) of Aruba?
Offer a terse response. 5.50e+08. What is the difference between the highest and the lowest Exports (in Local Currency Unit) in Denmark?
Your answer should be compact. 1.24e+11. What is the difference between the highest and the lowest Exports (in Local Currency Unit) of New Caledonia?
Your response must be concise. 1.70e+1. What is the difference between the highest and the lowest Exports (in Local Currency Unit) in Rwanda?
Offer a very short reply. 3.31e+1. 